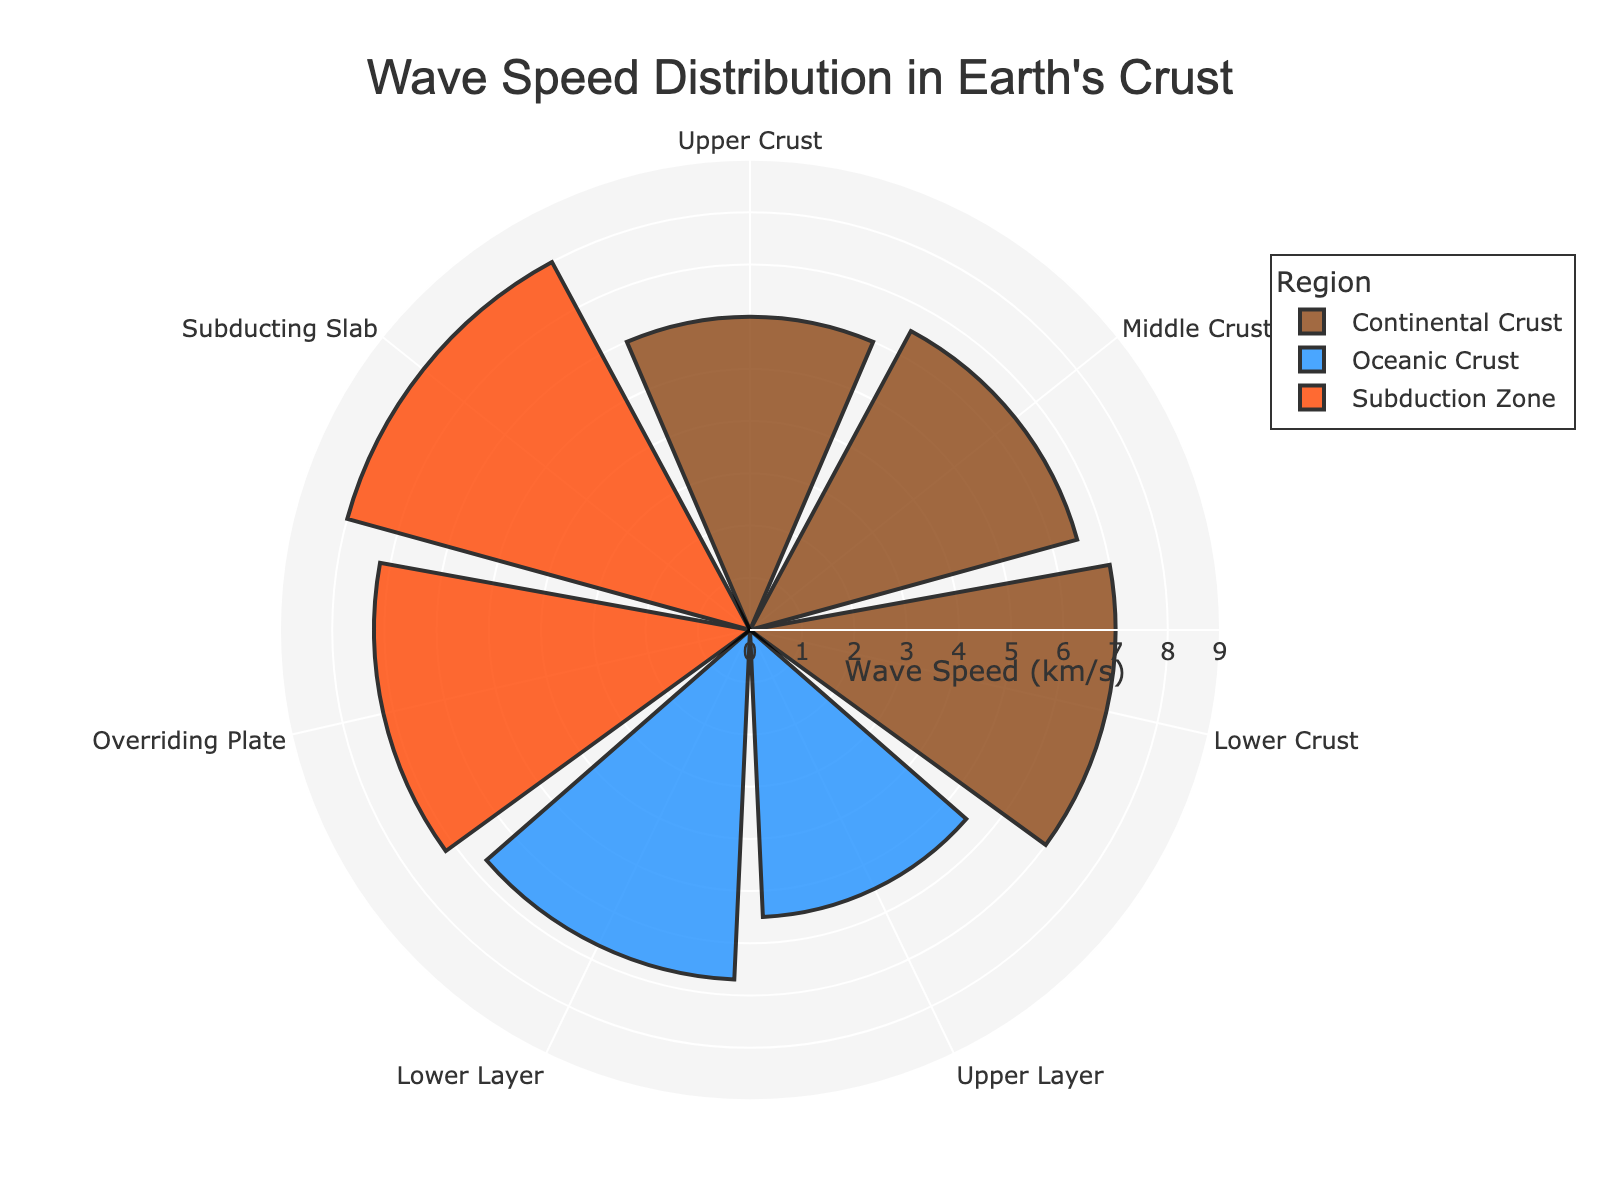What's the title of the figure? The title is typically found at the top center of the figure and is enclosed by single or double quotes. In this case, the title is 'Wave Speed Distribution in Earth's Crust' as specified in the code.
Answer: Wave Speed Distribution in Earth's Crust How many different regions are represented in the plot? By examining the legend and the distinct groups in the rose chart, we can count the number of unique region names. There are three: Continental Crust, Oceanic Crust, and Subduction Zone.
Answer: Three Which seismic layer shows the highest wave speed? To find the layer with the highest wave speed, we identify the longest radial bar within the plot. The longest bar is associated with the 'Subducting Slab' in the Subduction Zone, which has a wave speed of 8.0 km/s.
Answer: Subducting Slab What color represents the Oceanic Crust region? By looking at the legend, we can identify the color associated with the Oceanic Crust region. The color used is blue.
Answer: Blue Compare the wave speeds between the Upper Crust of the Continental Crust and the Upper Layer of the Oceanic Crust. Which is higher? Observing the radially arranged bars in the rose chart, the Upper Crust of the Continental Crust has a wave speed of 6.0 km/s, while the Upper Layer of the Oceanic Crust has a wave speed of 5.5 km/s. 6.0 km/s is higher.
Answer: Upper Crust of the Continental Crust What is the average wave speed in the Oceanic Crust region? The Oceanic Crust has two layers: Upper Layer (5.5 km/s) and Lower Layer (6.7 km/s). The average wave speed is calculated as (5.5 + 6.7) / 2 = 6.1 km/s.
Answer: 6.1 km/s Which region shows the greatest variation in wave speeds among its layers? By comparing the differences between the maximum and minimum speeds within each region: Continental Crust (7.0 - 6.0 = 1.0), Oceanic Crust (6.7 - 5.5 = 1.2), Subduction Zone (8.0 - 7.2 = 0.8). The Oceanic Crust has the greatest variation of 1.2.
Answer: Oceanic Crust What is the median wave speed in the Continental Crust region? The Continental Crust has three layers with wave speeds 6.0, 6.5, and 7.0 km/s. The median value of an odd number of sorted values is the middle one, which in this case is 6.5 km/s.
Answer: 6.5 km/s Are there any layers with identical wave speeds across different regions? By examining each bar's radial length for overlaps in value, we see that no two layers across different regions share the same wave speed value in the figure.
Answer: No 